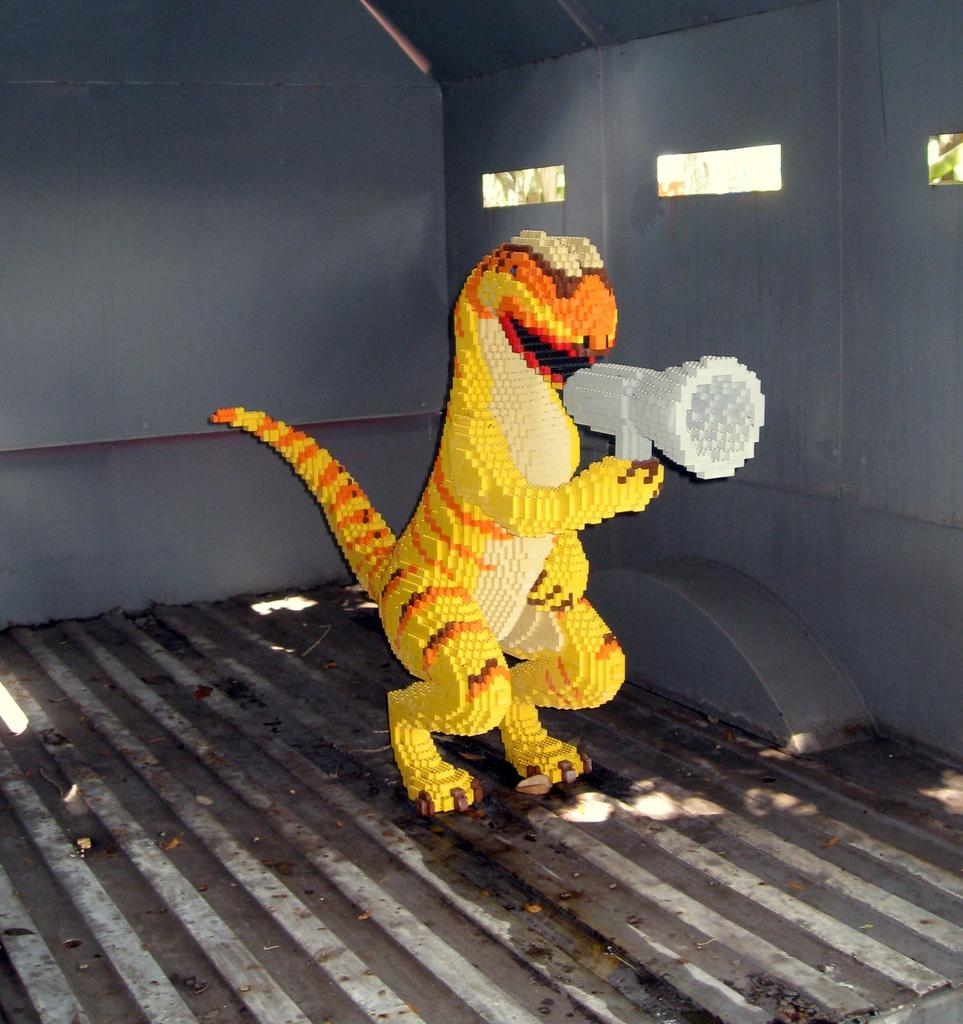What type of location is depicted in the image? The image is an inside view of a room. What is the main subject in the middle of the room? There is an animated dragon in the middle of the room. What type of fang does the dragon have in the image? There is no mention of the dragon having fangs in the image, nor is there any indication of the dragon's teeth. 